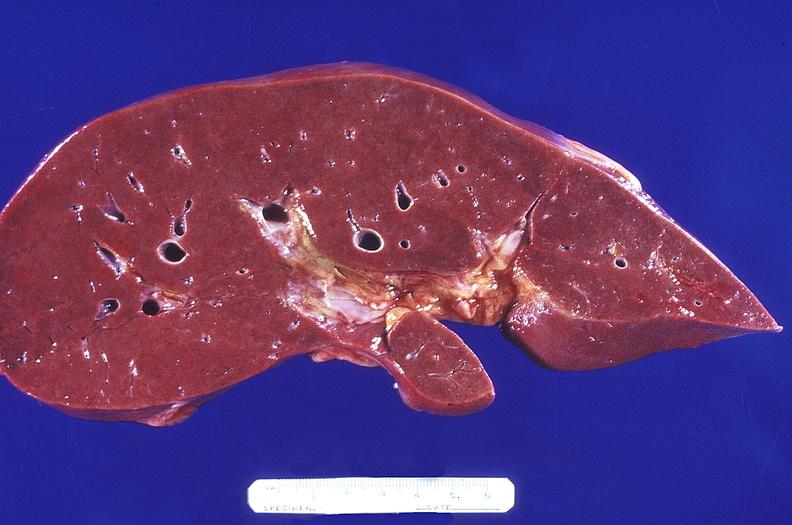does metastatic carcinoma prostate show normal liver?
Answer the question using a single word or phrase. No 